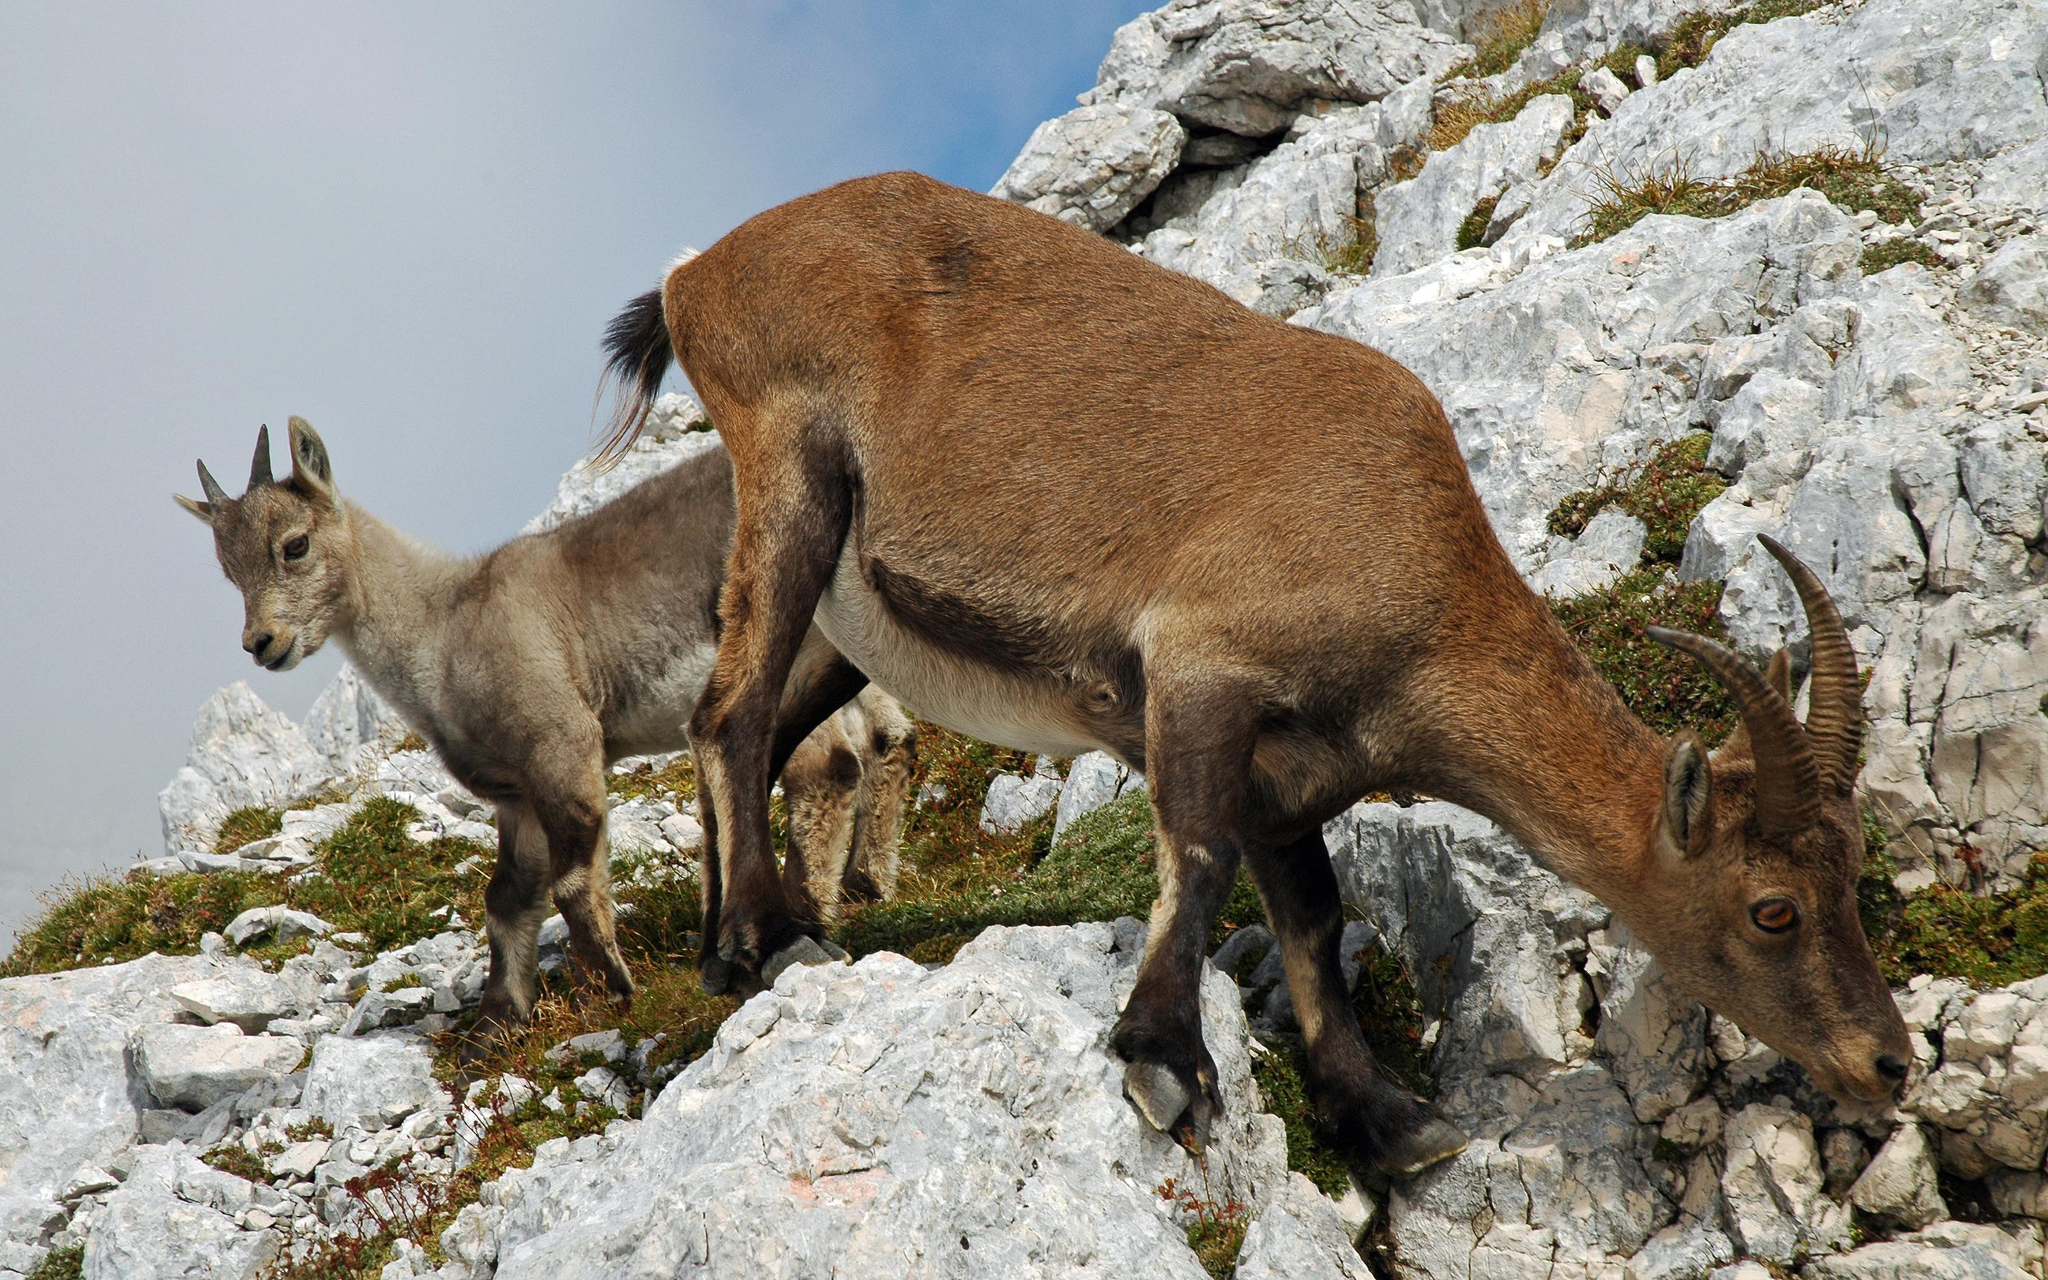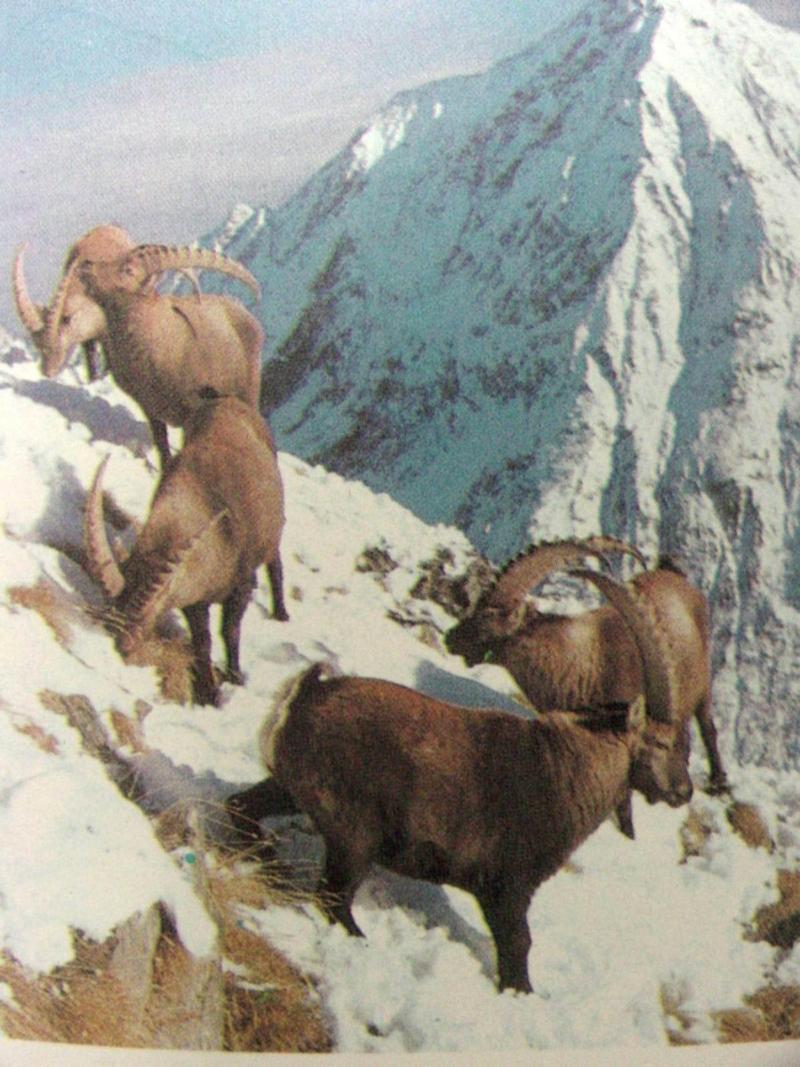The first image is the image on the left, the second image is the image on the right. Considering the images on both sides, is "One image has more than one but less than three mountain goats." valid? Answer yes or no. Yes. The first image is the image on the left, the second image is the image on the right. Given the left and right images, does the statement "One picture only has one goat in it." hold true? Answer yes or no. No. 